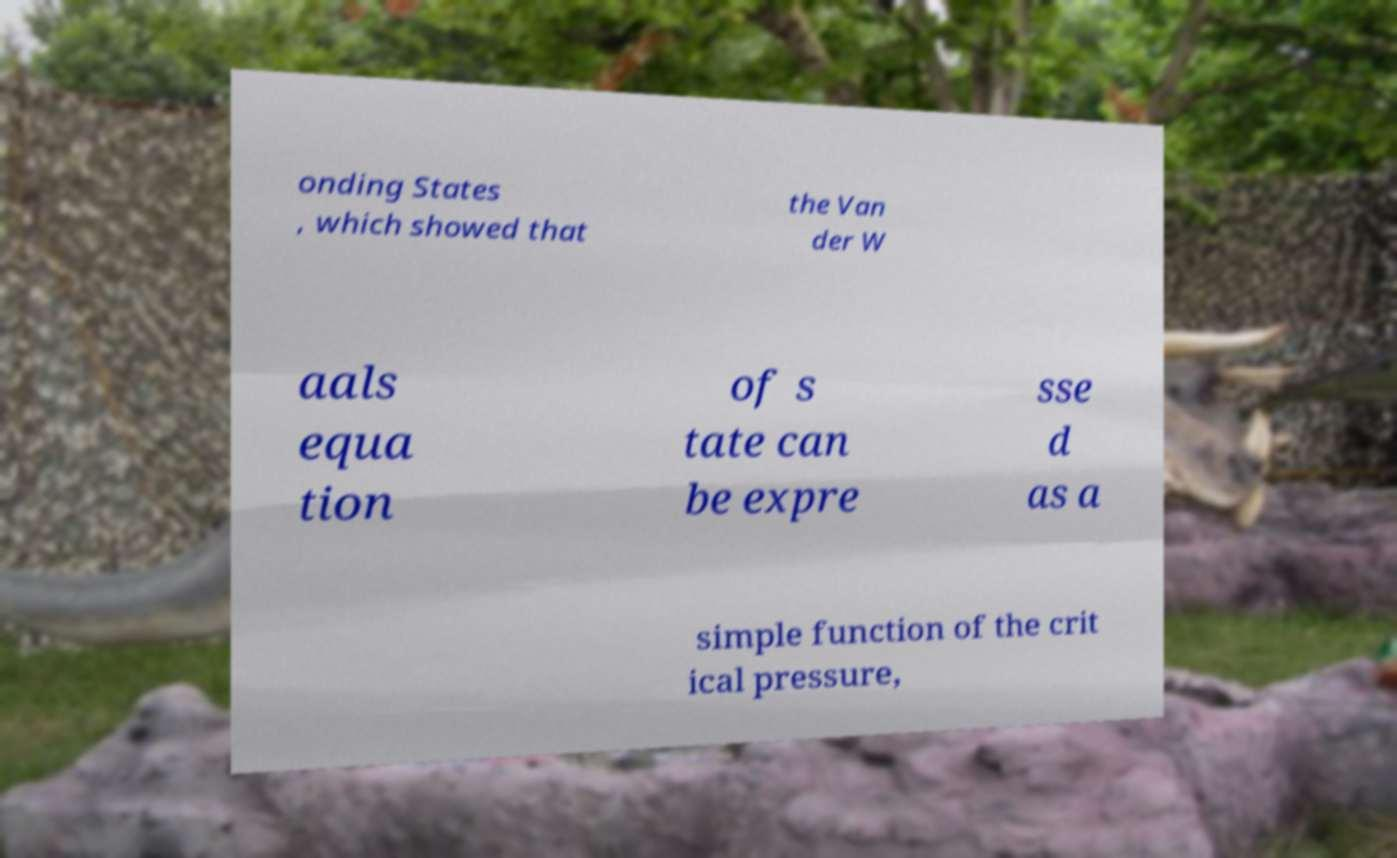Could you extract and type out the text from this image? onding States , which showed that the Van der W aals equa tion of s tate can be expre sse d as a simple function of the crit ical pressure, 